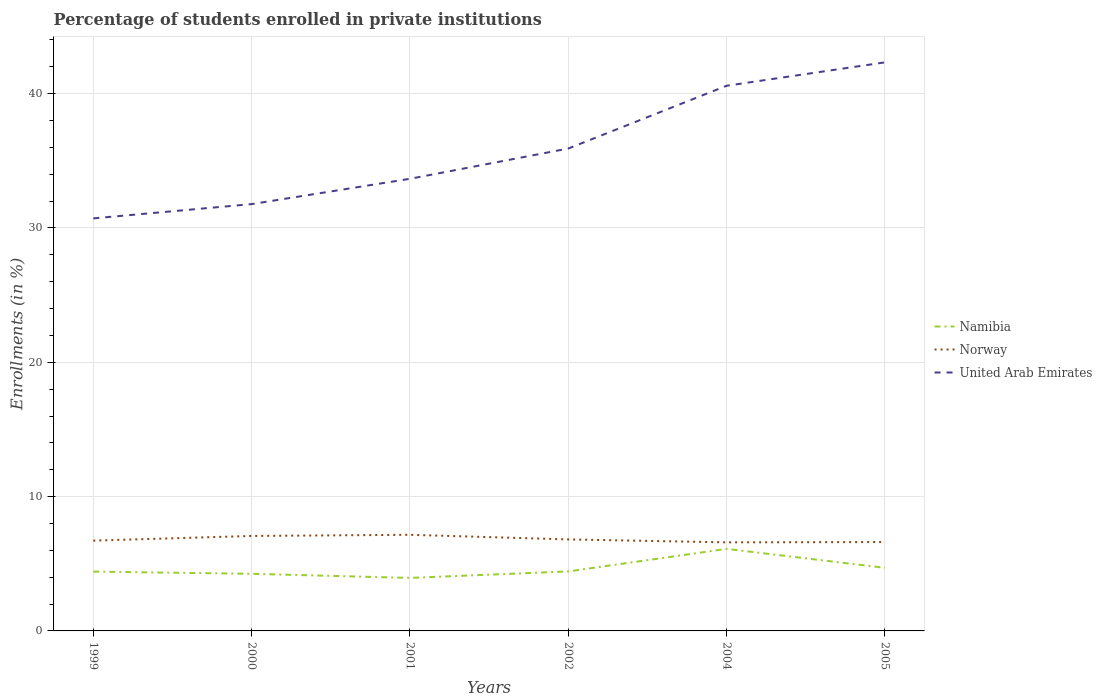How many different coloured lines are there?
Keep it short and to the point. 3. Across all years, what is the maximum percentage of trained teachers in Norway?
Offer a terse response. 6.59. What is the total percentage of trained teachers in Norway in the graph?
Offer a very short reply. 0.48. What is the difference between the highest and the second highest percentage of trained teachers in United Arab Emirates?
Make the answer very short. 11.62. Is the percentage of trained teachers in Norway strictly greater than the percentage of trained teachers in Namibia over the years?
Your answer should be compact. No. How many lines are there?
Your response must be concise. 3. How are the legend labels stacked?
Your answer should be very brief. Vertical. What is the title of the graph?
Your answer should be very brief. Percentage of students enrolled in private institutions. Does "Ukraine" appear as one of the legend labels in the graph?
Your answer should be compact. No. What is the label or title of the X-axis?
Your answer should be very brief. Years. What is the label or title of the Y-axis?
Give a very brief answer. Enrollments (in %). What is the Enrollments (in %) of Namibia in 1999?
Provide a succinct answer. 4.42. What is the Enrollments (in %) of Norway in 1999?
Your response must be concise. 6.72. What is the Enrollments (in %) of United Arab Emirates in 1999?
Provide a short and direct response. 30.71. What is the Enrollments (in %) in Namibia in 2000?
Ensure brevity in your answer.  4.25. What is the Enrollments (in %) of Norway in 2000?
Give a very brief answer. 7.07. What is the Enrollments (in %) of United Arab Emirates in 2000?
Your response must be concise. 31.78. What is the Enrollments (in %) in Namibia in 2001?
Give a very brief answer. 3.95. What is the Enrollments (in %) of Norway in 2001?
Ensure brevity in your answer.  7.16. What is the Enrollments (in %) of United Arab Emirates in 2001?
Make the answer very short. 33.66. What is the Enrollments (in %) of Namibia in 2002?
Provide a succinct answer. 4.43. What is the Enrollments (in %) of Norway in 2002?
Your answer should be very brief. 6.81. What is the Enrollments (in %) in United Arab Emirates in 2002?
Offer a very short reply. 35.91. What is the Enrollments (in %) of Namibia in 2004?
Provide a short and direct response. 6.11. What is the Enrollments (in %) in Norway in 2004?
Ensure brevity in your answer.  6.59. What is the Enrollments (in %) of United Arab Emirates in 2004?
Your answer should be very brief. 40.59. What is the Enrollments (in %) of Namibia in 2005?
Give a very brief answer. 4.7. What is the Enrollments (in %) in Norway in 2005?
Give a very brief answer. 6.62. What is the Enrollments (in %) of United Arab Emirates in 2005?
Provide a succinct answer. 42.33. Across all years, what is the maximum Enrollments (in %) of Namibia?
Provide a short and direct response. 6.11. Across all years, what is the maximum Enrollments (in %) of Norway?
Keep it short and to the point. 7.16. Across all years, what is the maximum Enrollments (in %) of United Arab Emirates?
Provide a succinct answer. 42.33. Across all years, what is the minimum Enrollments (in %) in Namibia?
Your answer should be compact. 3.95. Across all years, what is the minimum Enrollments (in %) of Norway?
Your answer should be compact. 6.59. Across all years, what is the minimum Enrollments (in %) of United Arab Emirates?
Your response must be concise. 30.71. What is the total Enrollments (in %) of Namibia in the graph?
Your response must be concise. 27.85. What is the total Enrollments (in %) in Norway in the graph?
Offer a terse response. 40.97. What is the total Enrollments (in %) of United Arab Emirates in the graph?
Make the answer very short. 214.98. What is the difference between the Enrollments (in %) of Namibia in 1999 and that in 2000?
Give a very brief answer. 0.17. What is the difference between the Enrollments (in %) of Norway in 1999 and that in 2000?
Your answer should be very brief. -0.35. What is the difference between the Enrollments (in %) of United Arab Emirates in 1999 and that in 2000?
Give a very brief answer. -1.06. What is the difference between the Enrollments (in %) of Namibia in 1999 and that in 2001?
Provide a succinct answer. 0.47. What is the difference between the Enrollments (in %) in Norway in 1999 and that in 2001?
Provide a short and direct response. -0.43. What is the difference between the Enrollments (in %) of United Arab Emirates in 1999 and that in 2001?
Ensure brevity in your answer.  -2.95. What is the difference between the Enrollments (in %) of Namibia in 1999 and that in 2002?
Your response must be concise. -0.01. What is the difference between the Enrollments (in %) of Norway in 1999 and that in 2002?
Your answer should be very brief. -0.09. What is the difference between the Enrollments (in %) of United Arab Emirates in 1999 and that in 2002?
Your answer should be very brief. -5.2. What is the difference between the Enrollments (in %) in Namibia in 1999 and that in 2004?
Provide a succinct answer. -1.69. What is the difference between the Enrollments (in %) in Norway in 1999 and that in 2004?
Ensure brevity in your answer.  0.13. What is the difference between the Enrollments (in %) in United Arab Emirates in 1999 and that in 2004?
Offer a terse response. -9.87. What is the difference between the Enrollments (in %) of Namibia in 1999 and that in 2005?
Your answer should be compact. -0.28. What is the difference between the Enrollments (in %) in Norway in 1999 and that in 2005?
Your answer should be compact. 0.1. What is the difference between the Enrollments (in %) of United Arab Emirates in 1999 and that in 2005?
Ensure brevity in your answer.  -11.62. What is the difference between the Enrollments (in %) of Namibia in 2000 and that in 2001?
Offer a terse response. 0.3. What is the difference between the Enrollments (in %) of Norway in 2000 and that in 2001?
Offer a very short reply. -0.09. What is the difference between the Enrollments (in %) in United Arab Emirates in 2000 and that in 2001?
Provide a short and direct response. -1.88. What is the difference between the Enrollments (in %) of Namibia in 2000 and that in 2002?
Keep it short and to the point. -0.18. What is the difference between the Enrollments (in %) of Norway in 2000 and that in 2002?
Your answer should be very brief. 0.26. What is the difference between the Enrollments (in %) in United Arab Emirates in 2000 and that in 2002?
Offer a terse response. -4.14. What is the difference between the Enrollments (in %) in Namibia in 2000 and that in 2004?
Make the answer very short. -1.86. What is the difference between the Enrollments (in %) in Norway in 2000 and that in 2004?
Ensure brevity in your answer.  0.48. What is the difference between the Enrollments (in %) in United Arab Emirates in 2000 and that in 2004?
Provide a short and direct response. -8.81. What is the difference between the Enrollments (in %) of Namibia in 2000 and that in 2005?
Make the answer very short. -0.45. What is the difference between the Enrollments (in %) of Norway in 2000 and that in 2005?
Make the answer very short. 0.45. What is the difference between the Enrollments (in %) of United Arab Emirates in 2000 and that in 2005?
Your answer should be very brief. -10.55. What is the difference between the Enrollments (in %) of Namibia in 2001 and that in 2002?
Keep it short and to the point. -0.48. What is the difference between the Enrollments (in %) of Norway in 2001 and that in 2002?
Provide a short and direct response. 0.34. What is the difference between the Enrollments (in %) in United Arab Emirates in 2001 and that in 2002?
Keep it short and to the point. -2.25. What is the difference between the Enrollments (in %) of Namibia in 2001 and that in 2004?
Your answer should be very brief. -2.16. What is the difference between the Enrollments (in %) of Norway in 2001 and that in 2004?
Your response must be concise. 0.56. What is the difference between the Enrollments (in %) of United Arab Emirates in 2001 and that in 2004?
Offer a terse response. -6.93. What is the difference between the Enrollments (in %) in Namibia in 2001 and that in 2005?
Offer a very short reply. -0.75. What is the difference between the Enrollments (in %) in Norway in 2001 and that in 2005?
Give a very brief answer. 0.54. What is the difference between the Enrollments (in %) in United Arab Emirates in 2001 and that in 2005?
Offer a very short reply. -8.67. What is the difference between the Enrollments (in %) of Namibia in 2002 and that in 2004?
Your answer should be compact. -1.68. What is the difference between the Enrollments (in %) of Norway in 2002 and that in 2004?
Your response must be concise. 0.22. What is the difference between the Enrollments (in %) of United Arab Emirates in 2002 and that in 2004?
Give a very brief answer. -4.67. What is the difference between the Enrollments (in %) of Namibia in 2002 and that in 2005?
Provide a succinct answer. -0.27. What is the difference between the Enrollments (in %) of Norway in 2002 and that in 2005?
Make the answer very short. 0.19. What is the difference between the Enrollments (in %) in United Arab Emirates in 2002 and that in 2005?
Keep it short and to the point. -6.42. What is the difference between the Enrollments (in %) of Namibia in 2004 and that in 2005?
Your answer should be very brief. 1.41. What is the difference between the Enrollments (in %) in Norway in 2004 and that in 2005?
Your response must be concise. -0.02. What is the difference between the Enrollments (in %) in United Arab Emirates in 2004 and that in 2005?
Offer a terse response. -1.74. What is the difference between the Enrollments (in %) in Namibia in 1999 and the Enrollments (in %) in Norway in 2000?
Keep it short and to the point. -2.65. What is the difference between the Enrollments (in %) of Namibia in 1999 and the Enrollments (in %) of United Arab Emirates in 2000?
Offer a very short reply. -27.36. What is the difference between the Enrollments (in %) of Norway in 1999 and the Enrollments (in %) of United Arab Emirates in 2000?
Provide a succinct answer. -25.05. What is the difference between the Enrollments (in %) in Namibia in 1999 and the Enrollments (in %) in Norway in 2001?
Your answer should be very brief. -2.74. What is the difference between the Enrollments (in %) in Namibia in 1999 and the Enrollments (in %) in United Arab Emirates in 2001?
Your answer should be compact. -29.24. What is the difference between the Enrollments (in %) of Norway in 1999 and the Enrollments (in %) of United Arab Emirates in 2001?
Your response must be concise. -26.94. What is the difference between the Enrollments (in %) in Namibia in 1999 and the Enrollments (in %) in Norway in 2002?
Your answer should be very brief. -2.39. What is the difference between the Enrollments (in %) of Namibia in 1999 and the Enrollments (in %) of United Arab Emirates in 2002?
Keep it short and to the point. -31.5. What is the difference between the Enrollments (in %) in Norway in 1999 and the Enrollments (in %) in United Arab Emirates in 2002?
Give a very brief answer. -29.19. What is the difference between the Enrollments (in %) of Namibia in 1999 and the Enrollments (in %) of Norway in 2004?
Your answer should be very brief. -2.18. What is the difference between the Enrollments (in %) in Namibia in 1999 and the Enrollments (in %) in United Arab Emirates in 2004?
Keep it short and to the point. -36.17. What is the difference between the Enrollments (in %) in Norway in 1999 and the Enrollments (in %) in United Arab Emirates in 2004?
Keep it short and to the point. -33.87. What is the difference between the Enrollments (in %) of Namibia in 1999 and the Enrollments (in %) of Norway in 2005?
Offer a very short reply. -2.2. What is the difference between the Enrollments (in %) of Namibia in 1999 and the Enrollments (in %) of United Arab Emirates in 2005?
Ensure brevity in your answer.  -37.91. What is the difference between the Enrollments (in %) in Norway in 1999 and the Enrollments (in %) in United Arab Emirates in 2005?
Provide a short and direct response. -35.61. What is the difference between the Enrollments (in %) of Namibia in 2000 and the Enrollments (in %) of Norway in 2001?
Keep it short and to the point. -2.9. What is the difference between the Enrollments (in %) of Namibia in 2000 and the Enrollments (in %) of United Arab Emirates in 2001?
Offer a very short reply. -29.41. What is the difference between the Enrollments (in %) of Norway in 2000 and the Enrollments (in %) of United Arab Emirates in 2001?
Provide a short and direct response. -26.59. What is the difference between the Enrollments (in %) of Namibia in 2000 and the Enrollments (in %) of Norway in 2002?
Offer a very short reply. -2.56. What is the difference between the Enrollments (in %) in Namibia in 2000 and the Enrollments (in %) in United Arab Emirates in 2002?
Ensure brevity in your answer.  -31.66. What is the difference between the Enrollments (in %) in Norway in 2000 and the Enrollments (in %) in United Arab Emirates in 2002?
Give a very brief answer. -28.84. What is the difference between the Enrollments (in %) in Namibia in 2000 and the Enrollments (in %) in Norway in 2004?
Give a very brief answer. -2.34. What is the difference between the Enrollments (in %) of Namibia in 2000 and the Enrollments (in %) of United Arab Emirates in 2004?
Offer a terse response. -36.34. What is the difference between the Enrollments (in %) of Norway in 2000 and the Enrollments (in %) of United Arab Emirates in 2004?
Offer a terse response. -33.52. What is the difference between the Enrollments (in %) in Namibia in 2000 and the Enrollments (in %) in Norway in 2005?
Provide a short and direct response. -2.37. What is the difference between the Enrollments (in %) in Namibia in 2000 and the Enrollments (in %) in United Arab Emirates in 2005?
Your response must be concise. -38.08. What is the difference between the Enrollments (in %) in Norway in 2000 and the Enrollments (in %) in United Arab Emirates in 2005?
Make the answer very short. -35.26. What is the difference between the Enrollments (in %) in Namibia in 2001 and the Enrollments (in %) in Norway in 2002?
Offer a terse response. -2.86. What is the difference between the Enrollments (in %) in Namibia in 2001 and the Enrollments (in %) in United Arab Emirates in 2002?
Your answer should be very brief. -31.97. What is the difference between the Enrollments (in %) in Norway in 2001 and the Enrollments (in %) in United Arab Emirates in 2002?
Offer a very short reply. -28.76. What is the difference between the Enrollments (in %) in Namibia in 2001 and the Enrollments (in %) in Norway in 2004?
Offer a terse response. -2.65. What is the difference between the Enrollments (in %) in Namibia in 2001 and the Enrollments (in %) in United Arab Emirates in 2004?
Make the answer very short. -36.64. What is the difference between the Enrollments (in %) in Norway in 2001 and the Enrollments (in %) in United Arab Emirates in 2004?
Ensure brevity in your answer.  -33.43. What is the difference between the Enrollments (in %) in Namibia in 2001 and the Enrollments (in %) in Norway in 2005?
Your answer should be very brief. -2.67. What is the difference between the Enrollments (in %) of Namibia in 2001 and the Enrollments (in %) of United Arab Emirates in 2005?
Keep it short and to the point. -38.38. What is the difference between the Enrollments (in %) of Norway in 2001 and the Enrollments (in %) of United Arab Emirates in 2005?
Your answer should be compact. -35.17. What is the difference between the Enrollments (in %) in Namibia in 2002 and the Enrollments (in %) in Norway in 2004?
Make the answer very short. -2.16. What is the difference between the Enrollments (in %) in Namibia in 2002 and the Enrollments (in %) in United Arab Emirates in 2004?
Make the answer very short. -36.16. What is the difference between the Enrollments (in %) in Norway in 2002 and the Enrollments (in %) in United Arab Emirates in 2004?
Give a very brief answer. -33.78. What is the difference between the Enrollments (in %) in Namibia in 2002 and the Enrollments (in %) in Norway in 2005?
Your answer should be compact. -2.19. What is the difference between the Enrollments (in %) in Namibia in 2002 and the Enrollments (in %) in United Arab Emirates in 2005?
Your answer should be very brief. -37.9. What is the difference between the Enrollments (in %) in Norway in 2002 and the Enrollments (in %) in United Arab Emirates in 2005?
Give a very brief answer. -35.52. What is the difference between the Enrollments (in %) of Namibia in 2004 and the Enrollments (in %) of Norway in 2005?
Your answer should be very brief. -0.51. What is the difference between the Enrollments (in %) of Namibia in 2004 and the Enrollments (in %) of United Arab Emirates in 2005?
Make the answer very short. -36.22. What is the difference between the Enrollments (in %) of Norway in 2004 and the Enrollments (in %) of United Arab Emirates in 2005?
Your response must be concise. -35.73. What is the average Enrollments (in %) of Namibia per year?
Make the answer very short. 4.64. What is the average Enrollments (in %) of Norway per year?
Give a very brief answer. 6.83. What is the average Enrollments (in %) of United Arab Emirates per year?
Ensure brevity in your answer.  35.83. In the year 1999, what is the difference between the Enrollments (in %) of Namibia and Enrollments (in %) of Norway?
Ensure brevity in your answer.  -2.3. In the year 1999, what is the difference between the Enrollments (in %) of Namibia and Enrollments (in %) of United Arab Emirates?
Your answer should be compact. -26.3. In the year 1999, what is the difference between the Enrollments (in %) in Norway and Enrollments (in %) in United Arab Emirates?
Your answer should be very brief. -23.99. In the year 2000, what is the difference between the Enrollments (in %) in Namibia and Enrollments (in %) in Norway?
Give a very brief answer. -2.82. In the year 2000, what is the difference between the Enrollments (in %) of Namibia and Enrollments (in %) of United Arab Emirates?
Make the answer very short. -27.52. In the year 2000, what is the difference between the Enrollments (in %) of Norway and Enrollments (in %) of United Arab Emirates?
Give a very brief answer. -24.71. In the year 2001, what is the difference between the Enrollments (in %) of Namibia and Enrollments (in %) of Norway?
Make the answer very short. -3.21. In the year 2001, what is the difference between the Enrollments (in %) of Namibia and Enrollments (in %) of United Arab Emirates?
Ensure brevity in your answer.  -29.71. In the year 2001, what is the difference between the Enrollments (in %) in Norway and Enrollments (in %) in United Arab Emirates?
Ensure brevity in your answer.  -26.5. In the year 2002, what is the difference between the Enrollments (in %) in Namibia and Enrollments (in %) in Norway?
Offer a very short reply. -2.38. In the year 2002, what is the difference between the Enrollments (in %) in Namibia and Enrollments (in %) in United Arab Emirates?
Provide a succinct answer. -31.48. In the year 2002, what is the difference between the Enrollments (in %) of Norway and Enrollments (in %) of United Arab Emirates?
Your response must be concise. -29.1. In the year 2004, what is the difference between the Enrollments (in %) of Namibia and Enrollments (in %) of Norway?
Your answer should be very brief. -0.49. In the year 2004, what is the difference between the Enrollments (in %) of Namibia and Enrollments (in %) of United Arab Emirates?
Offer a very short reply. -34.48. In the year 2004, what is the difference between the Enrollments (in %) in Norway and Enrollments (in %) in United Arab Emirates?
Your answer should be compact. -33.99. In the year 2005, what is the difference between the Enrollments (in %) of Namibia and Enrollments (in %) of Norway?
Your response must be concise. -1.92. In the year 2005, what is the difference between the Enrollments (in %) in Namibia and Enrollments (in %) in United Arab Emirates?
Make the answer very short. -37.63. In the year 2005, what is the difference between the Enrollments (in %) in Norway and Enrollments (in %) in United Arab Emirates?
Keep it short and to the point. -35.71. What is the ratio of the Enrollments (in %) of Namibia in 1999 to that in 2000?
Offer a terse response. 1.04. What is the ratio of the Enrollments (in %) of Norway in 1999 to that in 2000?
Offer a very short reply. 0.95. What is the ratio of the Enrollments (in %) in United Arab Emirates in 1999 to that in 2000?
Offer a terse response. 0.97. What is the ratio of the Enrollments (in %) in Namibia in 1999 to that in 2001?
Your answer should be very brief. 1.12. What is the ratio of the Enrollments (in %) of Norway in 1999 to that in 2001?
Make the answer very short. 0.94. What is the ratio of the Enrollments (in %) of United Arab Emirates in 1999 to that in 2001?
Your answer should be very brief. 0.91. What is the ratio of the Enrollments (in %) of Norway in 1999 to that in 2002?
Make the answer very short. 0.99. What is the ratio of the Enrollments (in %) in United Arab Emirates in 1999 to that in 2002?
Make the answer very short. 0.86. What is the ratio of the Enrollments (in %) in Namibia in 1999 to that in 2004?
Ensure brevity in your answer.  0.72. What is the ratio of the Enrollments (in %) in Norway in 1999 to that in 2004?
Give a very brief answer. 1.02. What is the ratio of the Enrollments (in %) of United Arab Emirates in 1999 to that in 2004?
Offer a terse response. 0.76. What is the ratio of the Enrollments (in %) of Namibia in 1999 to that in 2005?
Your response must be concise. 0.94. What is the ratio of the Enrollments (in %) in Norway in 1999 to that in 2005?
Your answer should be very brief. 1.02. What is the ratio of the Enrollments (in %) in United Arab Emirates in 1999 to that in 2005?
Give a very brief answer. 0.73. What is the ratio of the Enrollments (in %) in Namibia in 2000 to that in 2001?
Offer a terse response. 1.08. What is the ratio of the Enrollments (in %) in Norway in 2000 to that in 2001?
Provide a short and direct response. 0.99. What is the ratio of the Enrollments (in %) in United Arab Emirates in 2000 to that in 2001?
Ensure brevity in your answer.  0.94. What is the ratio of the Enrollments (in %) of Namibia in 2000 to that in 2002?
Provide a short and direct response. 0.96. What is the ratio of the Enrollments (in %) of Norway in 2000 to that in 2002?
Offer a very short reply. 1.04. What is the ratio of the Enrollments (in %) in United Arab Emirates in 2000 to that in 2002?
Provide a succinct answer. 0.88. What is the ratio of the Enrollments (in %) in Namibia in 2000 to that in 2004?
Make the answer very short. 0.7. What is the ratio of the Enrollments (in %) in Norway in 2000 to that in 2004?
Provide a succinct answer. 1.07. What is the ratio of the Enrollments (in %) in United Arab Emirates in 2000 to that in 2004?
Your answer should be very brief. 0.78. What is the ratio of the Enrollments (in %) in Namibia in 2000 to that in 2005?
Keep it short and to the point. 0.9. What is the ratio of the Enrollments (in %) in Norway in 2000 to that in 2005?
Give a very brief answer. 1.07. What is the ratio of the Enrollments (in %) of United Arab Emirates in 2000 to that in 2005?
Keep it short and to the point. 0.75. What is the ratio of the Enrollments (in %) of Namibia in 2001 to that in 2002?
Give a very brief answer. 0.89. What is the ratio of the Enrollments (in %) in Norway in 2001 to that in 2002?
Ensure brevity in your answer.  1.05. What is the ratio of the Enrollments (in %) in United Arab Emirates in 2001 to that in 2002?
Your response must be concise. 0.94. What is the ratio of the Enrollments (in %) of Namibia in 2001 to that in 2004?
Offer a terse response. 0.65. What is the ratio of the Enrollments (in %) in Norway in 2001 to that in 2004?
Ensure brevity in your answer.  1.09. What is the ratio of the Enrollments (in %) of United Arab Emirates in 2001 to that in 2004?
Offer a terse response. 0.83. What is the ratio of the Enrollments (in %) of Namibia in 2001 to that in 2005?
Provide a short and direct response. 0.84. What is the ratio of the Enrollments (in %) in Norway in 2001 to that in 2005?
Ensure brevity in your answer.  1.08. What is the ratio of the Enrollments (in %) of United Arab Emirates in 2001 to that in 2005?
Your answer should be very brief. 0.8. What is the ratio of the Enrollments (in %) in Namibia in 2002 to that in 2004?
Make the answer very short. 0.73. What is the ratio of the Enrollments (in %) of Norway in 2002 to that in 2004?
Your response must be concise. 1.03. What is the ratio of the Enrollments (in %) of United Arab Emirates in 2002 to that in 2004?
Ensure brevity in your answer.  0.88. What is the ratio of the Enrollments (in %) in Namibia in 2002 to that in 2005?
Provide a succinct answer. 0.94. What is the ratio of the Enrollments (in %) of Norway in 2002 to that in 2005?
Your answer should be very brief. 1.03. What is the ratio of the Enrollments (in %) in United Arab Emirates in 2002 to that in 2005?
Give a very brief answer. 0.85. What is the ratio of the Enrollments (in %) of Namibia in 2004 to that in 2005?
Offer a very short reply. 1.3. What is the ratio of the Enrollments (in %) in Norway in 2004 to that in 2005?
Your answer should be very brief. 1. What is the ratio of the Enrollments (in %) of United Arab Emirates in 2004 to that in 2005?
Give a very brief answer. 0.96. What is the difference between the highest and the second highest Enrollments (in %) of Namibia?
Make the answer very short. 1.41. What is the difference between the highest and the second highest Enrollments (in %) of Norway?
Keep it short and to the point. 0.09. What is the difference between the highest and the second highest Enrollments (in %) in United Arab Emirates?
Make the answer very short. 1.74. What is the difference between the highest and the lowest Enrollments (in %) of Namibia?
Your response must be concise. 2.16. What is the difference between the highest and the lowest Enrollments (in %) in Norway?
Your answer should be compact. 0.56. What is the difference between the highest and the lowest Enrollments (in %) of United Arab Emirates?
Ensure brevity in your answer.  11.62. 